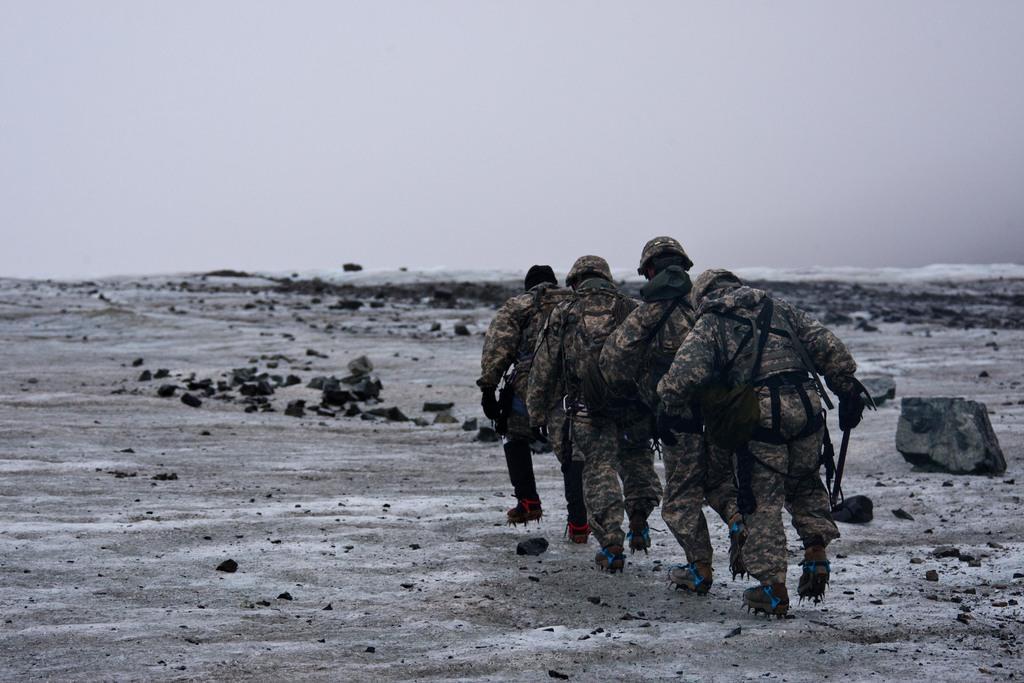In one or two sentences, can you explain what this image depicts? This picture shows few people walking with helmets on their heads and we see spikes to their shoes and they wore bags and we see a cloudy sky and few rocks on the ground. 